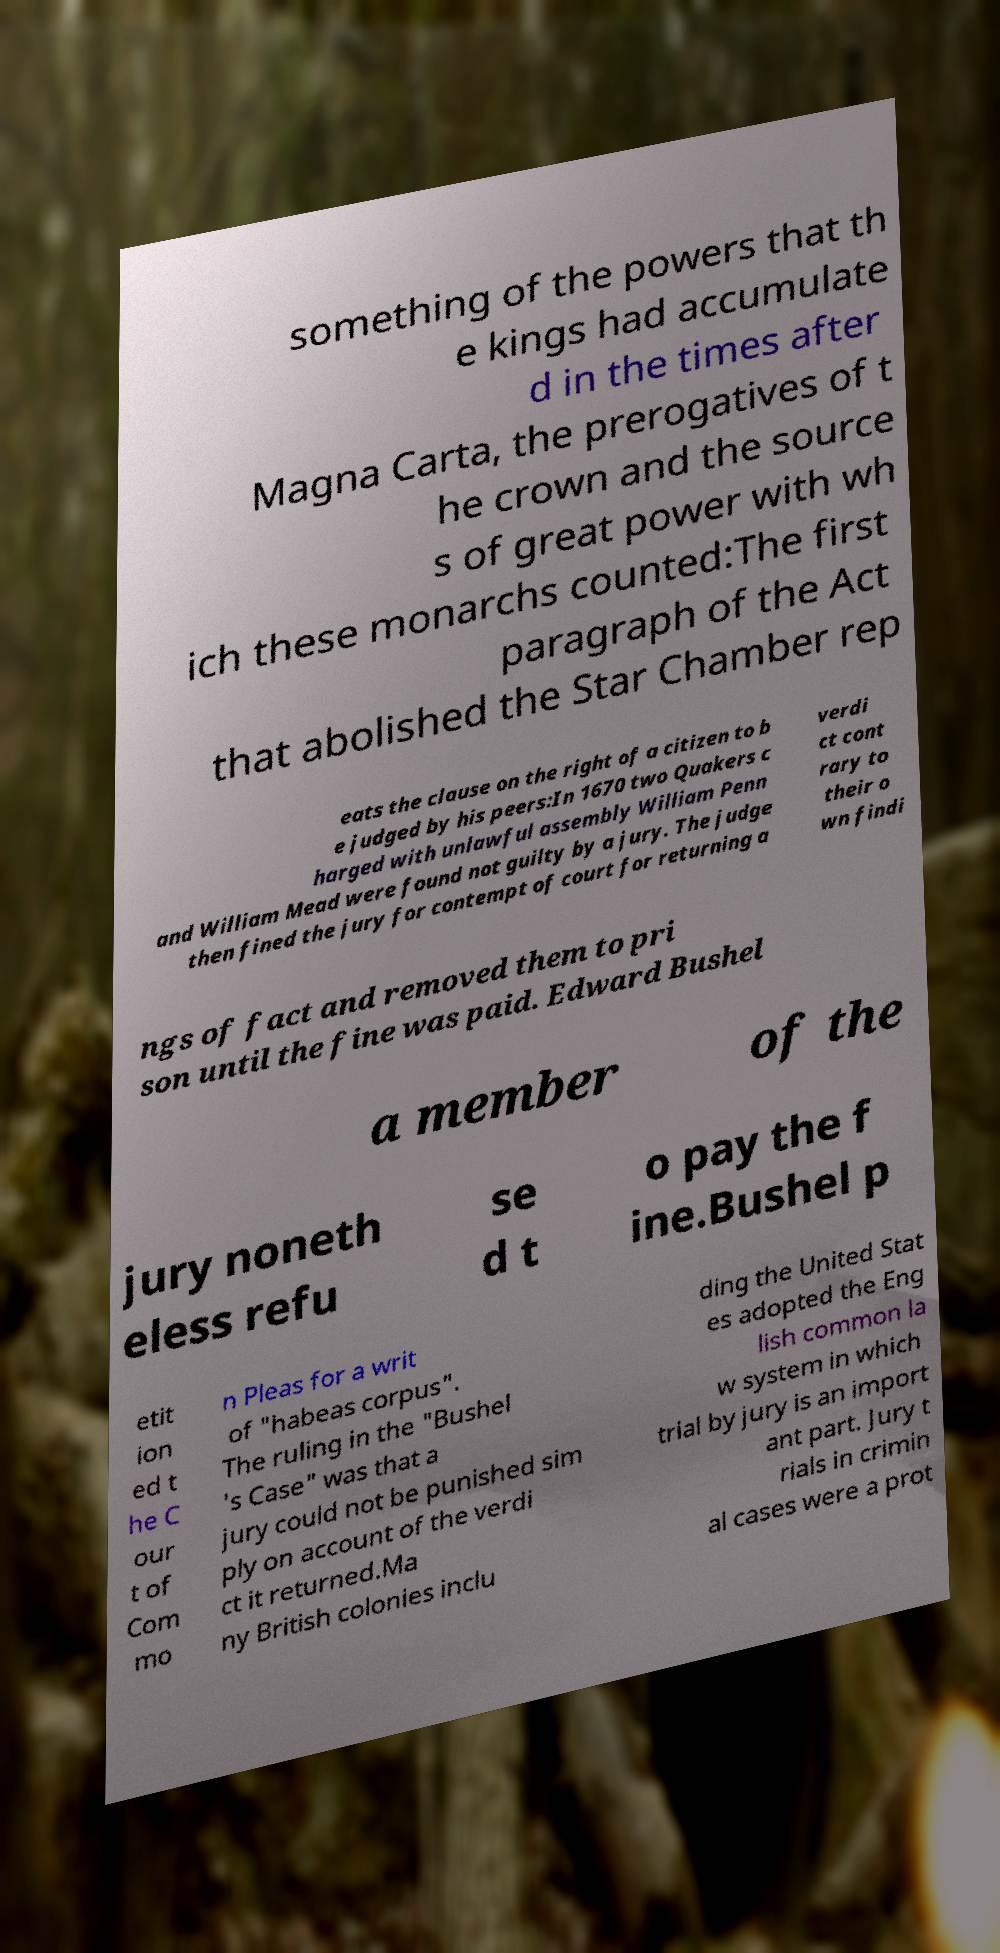Please read and relay the text visible in this image. What does it say? something of the powers that th e kings had accumulate d in the times after Magna Carta, the prerogatives of t he crown and the source s of great power with wh ich these monarchs counted:The first paragraph of the Act that abolished the Star Chamber rep eats the clause on the right of a citizen to b e judged by his peers:In 1670 two Quakers c harged with unlawful assembly William Penn and William Mead were found not guilty by a jury. The judge then fined the jury for contempt of court for returning a verdi ct cont rary to their o wn findi ngs of fact and removed them to pri son until the fine was paid. Edward Bushel a member of the jury noneth eless refu se d t o pay the f ine.Bushel p etit ion ed t he C our t of Com mo n Pleas for a writ of "habeas corpus". The ruling in the "Bushel 's Case" was that a jury could not be punished sim ply on account of the verdi ct it returned.Ma ny British colonies inclu ding the United Stat es adopted the Eng lish common la w system in which trial by jury is an import ant part. Jury t rials in crimin al cases were a prot 